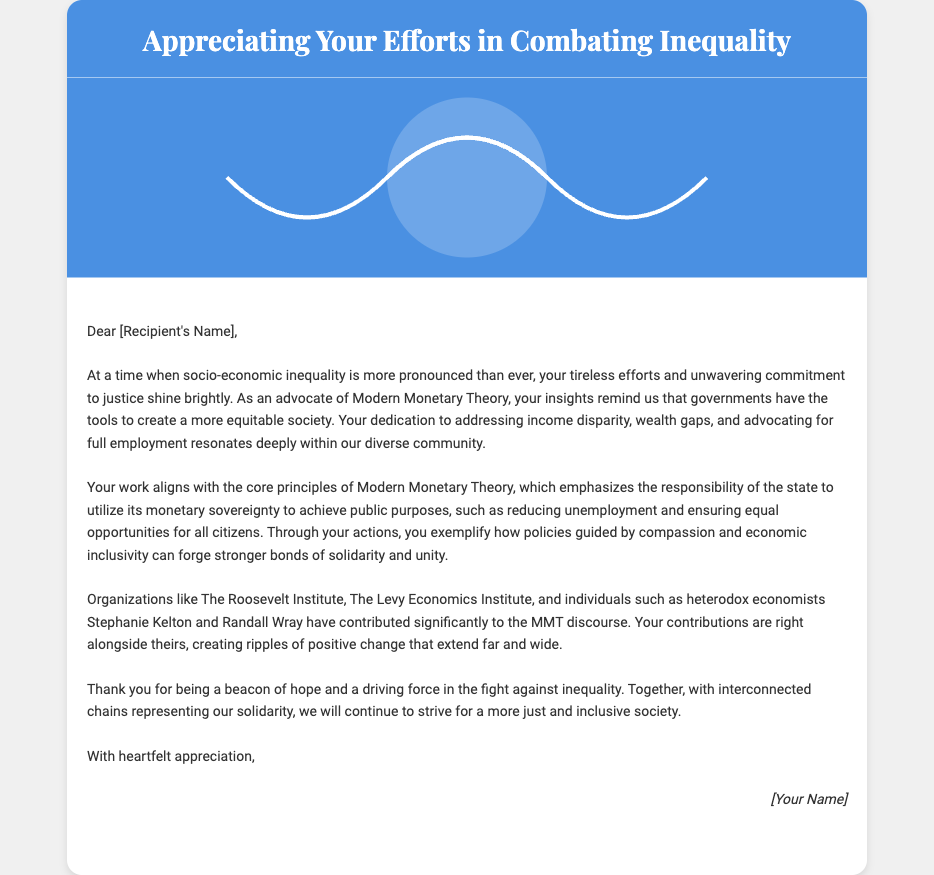What is the title of the card? The title of the card is displayed prominently at the top of the document.
Answer: Appreciating Your Efforts in Combating Inequality Who is the card addressed to? The card is personalized with a placeholder to indicate where the recipient's name should be placed.
Answer: [Recipient's Name] What are the main issues addressed in the card? The card discusses socio-economic inequality and the advocacy of Modern Monetary Theory as solutions.
Answer: Socio-economic inequality Which principle of Modern Monetary Theory is highlighted? The card emphasizes the responsibility of the state to achieve public purposes, a key tenet of MMT.
Answer: Monetary sovereignty Which notable heterodox economists are mentioned? The card lists key individuals who have contributed to the MMT discourse, serving as examples of advocacy.
Answer: Stephanie Kelton and Randall Wray What does the design of the card symbolize? The interconnected chains in the design represent a broader theme in the card related to community and solidarity efforts.
Answer: Solidarity and unity What kind of organizations are referred to in the card? The card mentions organizations that contribute to the discussion of MMT, illustrating the community involved.
Answer: The Roosevelt Institute and The Levy Economics Institute What type of appreciation does the sender express? The sender expresses gratitude for being a "beacon of hope" in the fight against inequality.
Answer: Heartfelt appreciation 